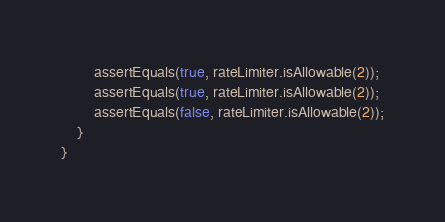<code> <loc_0><loc_0><loc_500><loc_500><_Java_>		assertEquals(true, rateLimiter.isAllowable(2));
		assertEquals(true, rateLimiter.isAllowable(2));
		assertEquals(false, rateLimiter.isAllowable(2));
	}
}
</code> 